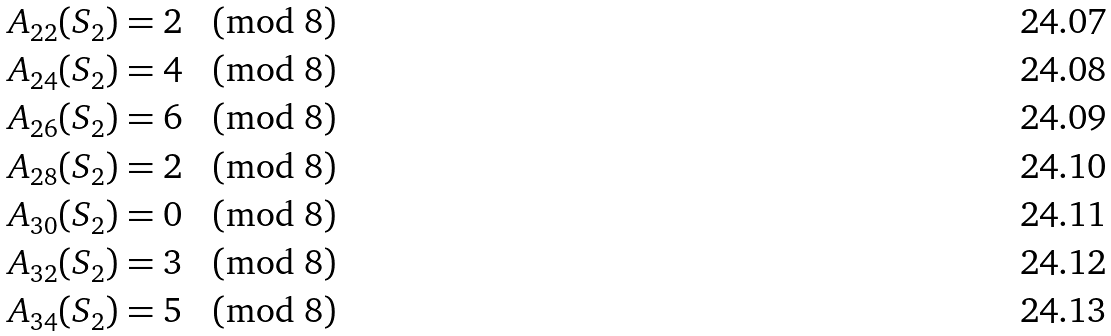Convert formula to latex. <formula><loc_0><loc_0><loc_500><loc_500>A _ { 2 2 } ( S _ { 2 } ) & = 2 \pmod { 8 } \\ A _ { 2 4 } ( S _ { 2 } ) & = 4 \pmod { 8 } \\ A _ { 2 6 } ( S _ { 2 } ) & = 6 \pmod { 8 } \\ A _ { 2 8 } ( S _ { 2 } ) & = 2 \pmod { 8 } \\ A _ { 3 0 } ( S _ { 2 } ) & = 0 \pmod { 8 } \\ A _ { 3 2 } ( S _ { 2 } ) & = 3 \pmod { 8 } \\ A _ { 3 4 } ( S _ { 2 } ) & = 5 \pmod { 8 }</formula> 